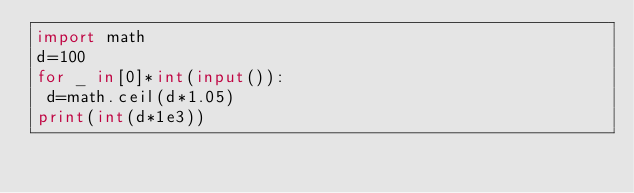Convert code to text. <code><loc_0><loc_0><loc_500><loc_500><_Python_>import math
d=100
for _ in[0]*int(input()):
 d=math.ceil(d*1.05)
print(int(d*1e3))
</code> 